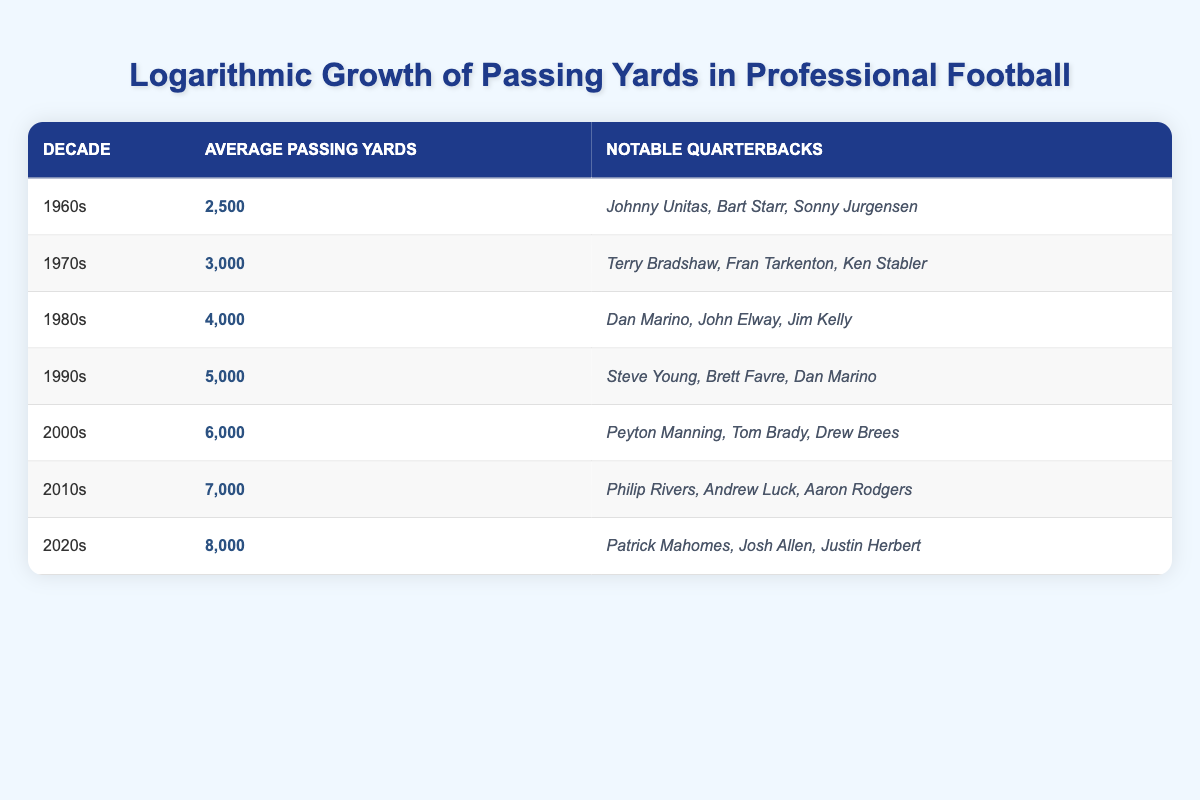What was the average passing yards in the 1980s? The table shows that in the 1980s, the average passing yards was listed as 4,000.
Answer: 4,000 Which decades had an average passing yardage of 6,000 or more? By reviewing the table, the decades with an average passing yards of 6,000 or more are the 2000s (6,000), 2010s (7,000), and 2020s (8,000).
Answer: 2000s, 2010s, 2020s Is it true that the average passing yards increased by 1,000 yards from the 1990s to the 2000s? Comparing the average passing yards, the 1990s had 5,000 yards and the 2000s had 6,000 yards. The difference is 1,000 yards, so the statement is true.
Answer: Yes What is the total average passing yards of the 1960s, 1970s, and 1980s combined? The average passing yards for these decades are: 1960s (2,500), 1970s (3,000), and 1980s (4,000). Adding these gives us 2,500 + 3,000 + 4,000 = 9,500.
Answer: 9,500 Which notable quarterbacks were active in the 1990s? The table lists notable quarterbacks in the 1990s as Steve Young, Brett Favre, and Dan Marino.
Answer: Steve Young, Brett Favre, Dan Marino How many decades had an average passing yards of less than 5,000? The table indicates that the only decades with average passing yards less than 5,000 are the 1960s (2,500), 1970s (3,000), and 1980s (4,000). This sums up to three decades.
Answer: 3 Is it possible to identify a trend in average passing yards over the decades from the table? The data indicates a clear upward trend: the average passing yards increases consistently by 1,000 yards per decade from the 1960s (2,500) through the 2020s (8,000), confirming the trend.
Answer: Yes What was the average passing yards in the 2000s, and who were the notable QBs? For the 2000s, the average passing yards were 6,000, and the notable quarterbacks mentioned were Peyton Manning, Tom Brady, and Drew Brees.
Answer: 6,000; Peyton Manning, Tom Brady, Drew Brees 